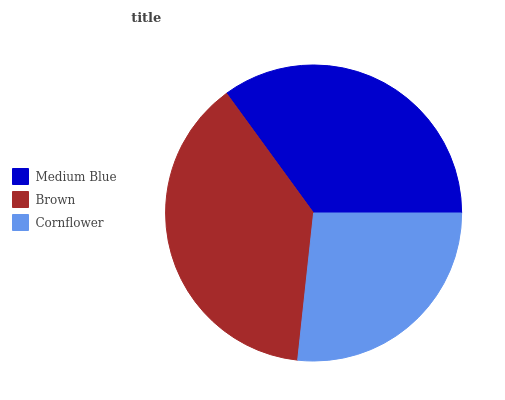Is Cornflower the minimum?
Answer yes or no. Yes. Is Brown the maximum?
Answer yes or no. Yes. Is Brown the minimum?
Answer yes or no. No. Is Cornflower the maximum?
Answer yes or no. No. Is Brown greater than Cornflower?
Answer yes or no. Yes. Is Cornflower less than Brown?
Answer yes or no. Yes. Is Cornflower greater than Brown?
Answer yes or no. No. Is Brown less than Cornflower?
Answer yes or no. No. Is Medium Blue the high median?
Answer yes or no. Yes. Is Medium Blue the low median?
Answer yes or no. Yes. Is Brown the high median?
Answer yes or no. No. Is Cornflower the low median?
Answer yes or no. No. 